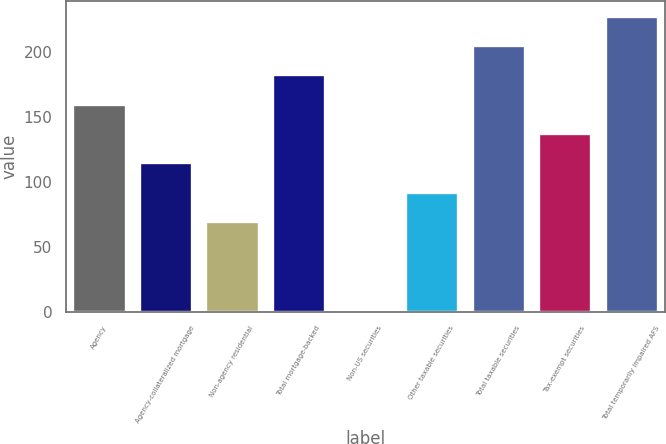Convert chart to OTSL. <chart><loc_0><loc_0><loc_500><loc_500><bar_chart><fcel>Agency<fcel>Agency-collateralized mortgage<fcel>Non-agency residential<fcel>Total mortgage-backed<fcel>Non-US securities<fcel>Other taxable securities<fcel>Total taxable securities<fcel>Tax-exempt securities<fcel>Total temporarily impaired AFS<nl><fcel>160.2<fcel>115<fcel>69.8<fcel>182.8<fcel>2<fcel>92.4<fcel>205.4<fcel>137.6<fcel>228<nl></chart> 